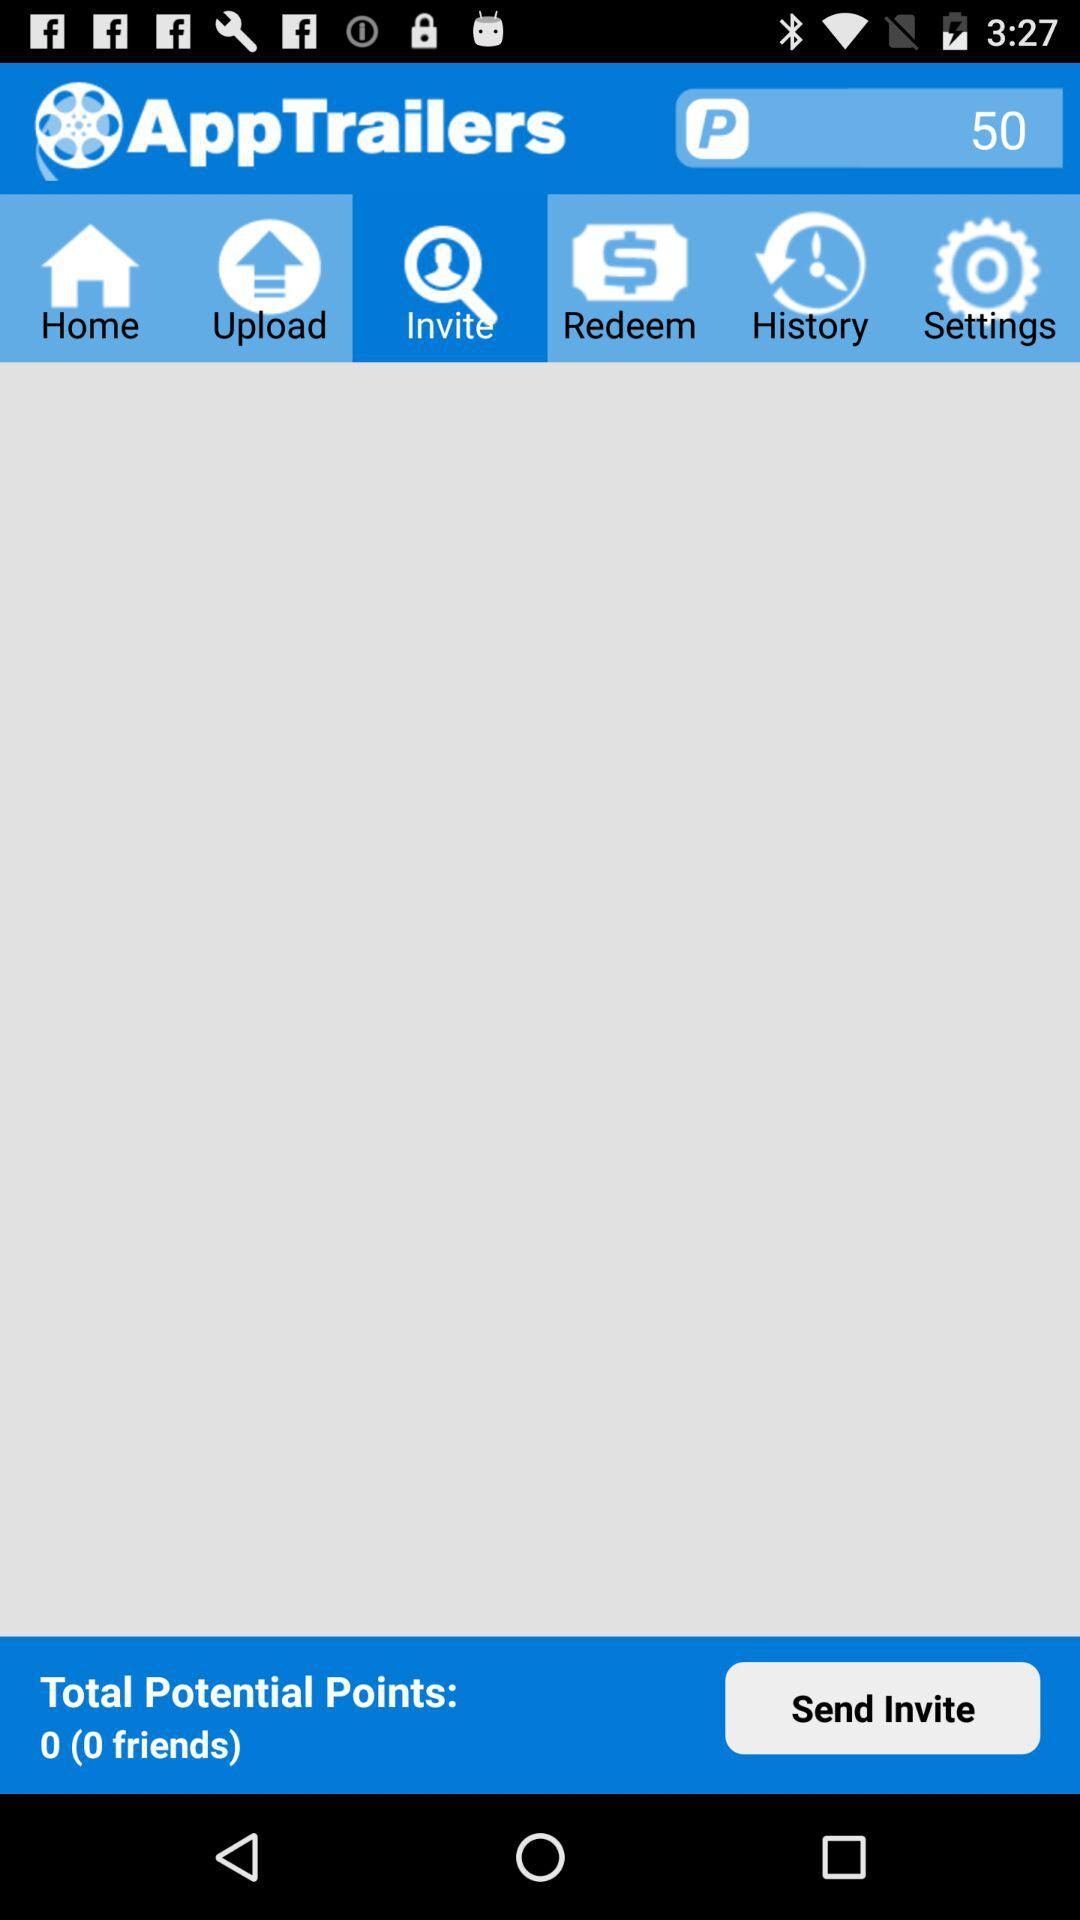What is the number of friends?
When the provided information is insufficient, respond with <no answer>. <no answer> 